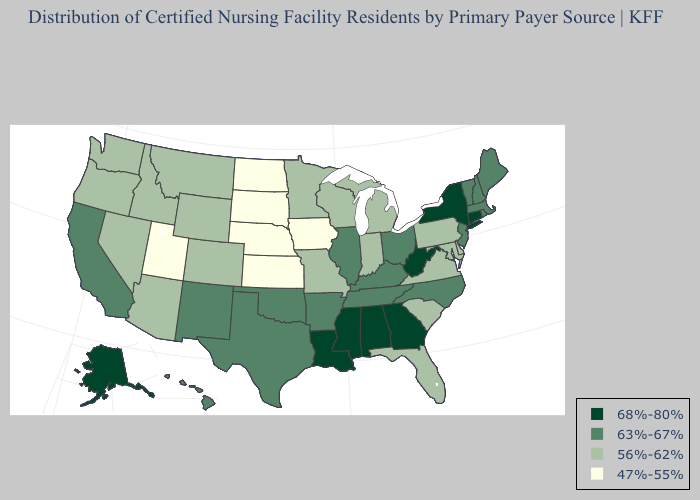Name the states that have a value in the range 56%-62%?
Be succinct. Arizona, Colorado, Delaware, Florida, Idaho, Indiana, Maryland, Michigan, Minnesota, Missouri, Montana, Nevada, Oregon, Pennsylvania, South Carolina, Virginia, Washington, Wisconsin, Wyoming. Does New Hampshire have the same value as Alaska?
Concise answer only. No. Does Florida have a higher value than Missouri?
Quick response, please. No. Among the states that border Texas , which have the lowest value?
Concise answer only. Arkansas, New Mexico, Oklahoma. Does the map have missing data?
Quick response, please. No. Does Delaware have a lower value than Pennsylvania?
Give a very brief answer. No. What is the value of New Jersey?
Keep it brief. 63%-67%. Does Utah have the lowest value in the West?
Concise answer only. Yes. Which states have the highest value in the USA?
Keep it brief. Alabama, Alaska, Connecticut, Georgia, Louisiana, Mississippi, New York, West Virginia. Does Oklahoma have the lowest value in the South?
Concise answer only. No. Name the states that have a value in the range 68%-80%?
Concise answer only. Alabama, Alaska, Connecticut, Georgia, Louisiana, Mississippi, New York, West Virginia. Which states hav the highest value in the South?
Give a very brief answer. Alabama, Georgia, Louisiana, Mississippi, West Virginia. Does Tennessee have the highest value in the South?
Be succinct. No. What is the value of Ohio?
Keep it brief. 63%-67%. What is the highest value in the South ?
Short answer required. 68%-80%. 